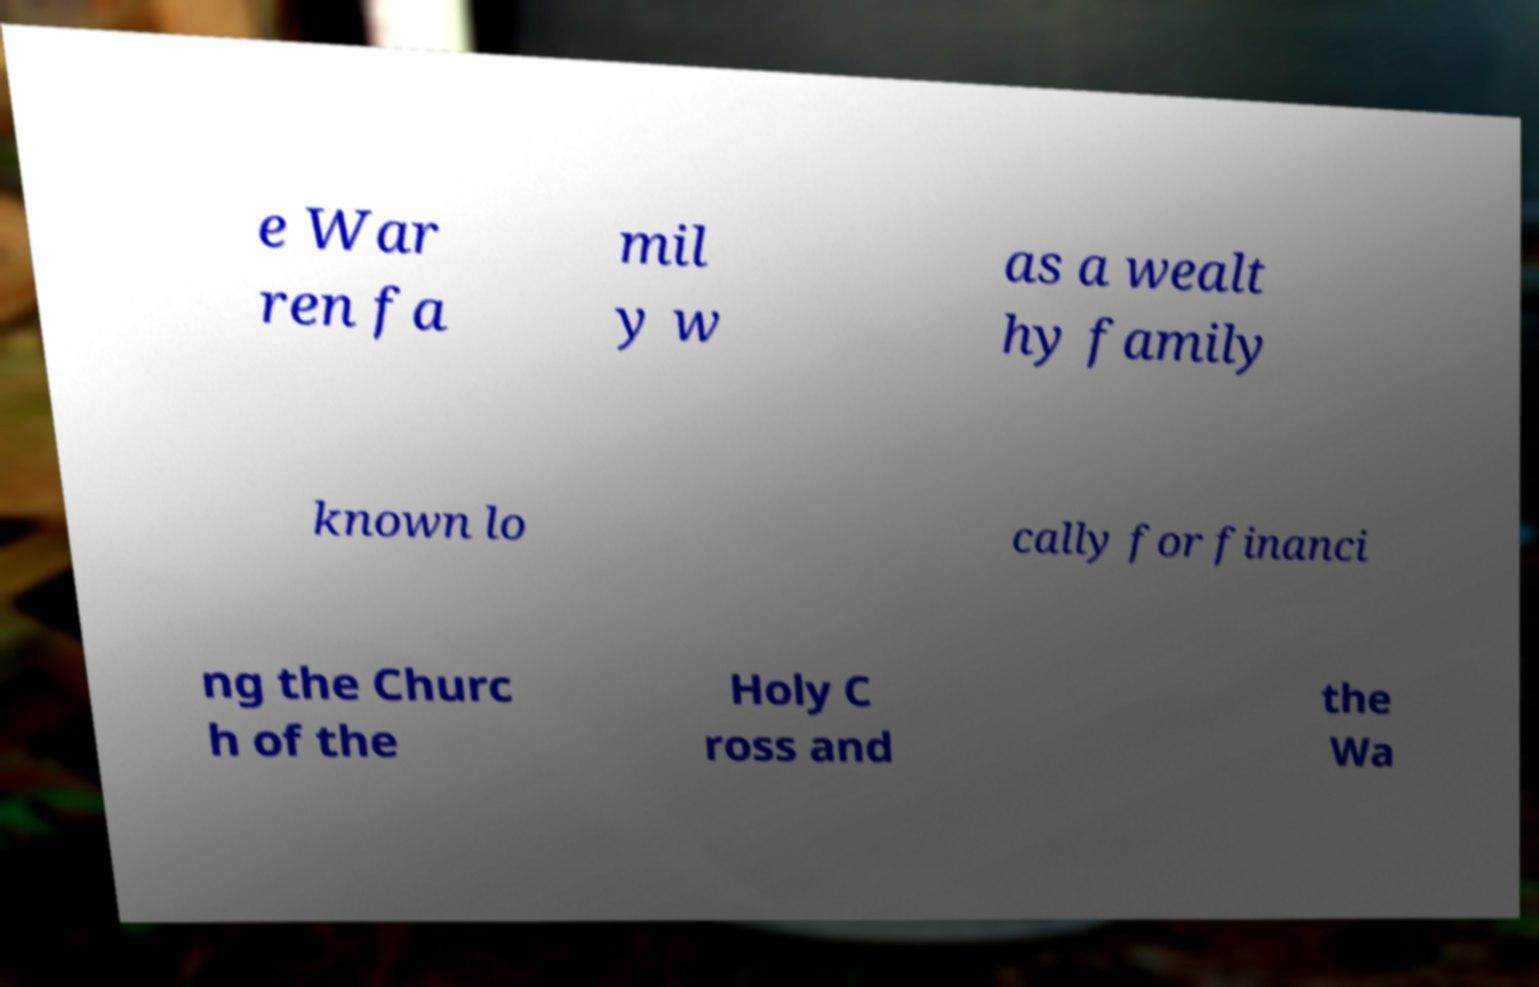Please read and relay the text visible in this image. What does it say? e War ren fa mil y w as a wealt hy family known lo cally for financi ng the Churc h of the Holy C ross and the Wa 